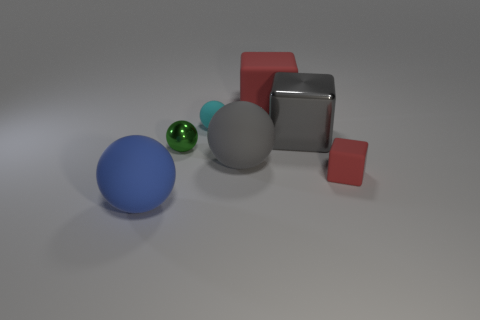What is the color of the small metallic thing that is the same shape as the big blue thing?
Make the answer very short. Green. There is a gray object that is the same shape as the large blue matte thing; what is its size?
Make the answer very short. Large. There is a cube that is in front of the small cyan matte sphere and on the left side of the small red rubber object; what is its material?
Make the answer very short. Metal. Is the color of the matte block that is behind the cyan matte object the same as the tiny rubber block?
Offer a terse response. Yes. Does the metallic cube have the same color as the big sphere that is to the right of the tiny matte sphere?
Provide a short and direct response. Yes. There is a large gray rubber sphere; are there any small balls on the right side of it?
Provide a short and direct response. No. Do the large blue ball and the tiny red block have the same material?
Make the answer very short. Yes. There is a green thing that is the same size as the cyan object; what material is it?
Provide a short and direct response. Metal. How many things are either things behind the large blue ball or gray spheres?
Your answer should be very brief. 6. Are there the same number of big rubber objects to the left of the big blue rubber sphere and gray spheres?
Your answer should be very brief. No. 